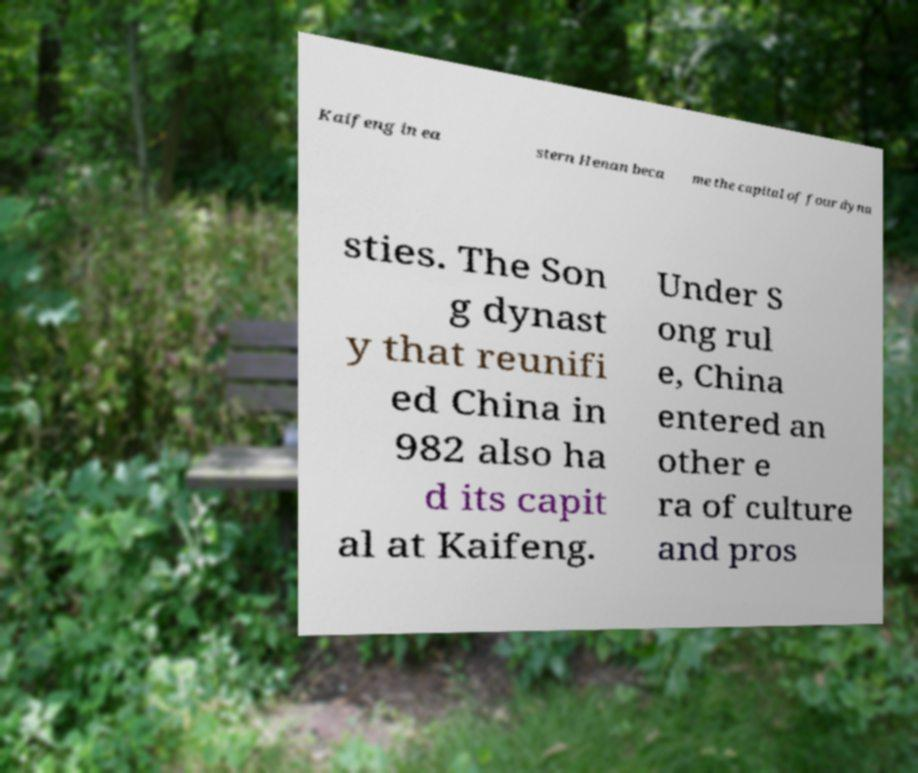Can you accurately transcribe the text from the provided image for me? Kaifeng in ea stern Henan beca me the capital of four dyna sties. The Son g dynast y that reunifi ed China in 982 also ha d its capit al at Kaifeng. Under S ong rul e, China entered an other e ra of culture and pros 